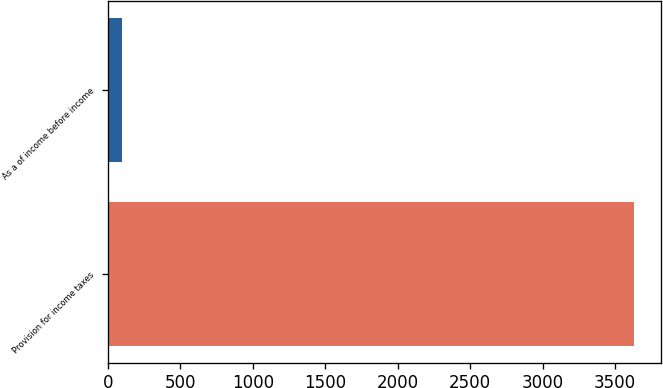<chart> <loc_0><loc_0><loc_500><loc_500><bar_chart><fcel>Provision for income taxes<fcel>As a of income before income<nl><fcel>3634<fcel>99.5<nl></chart> 